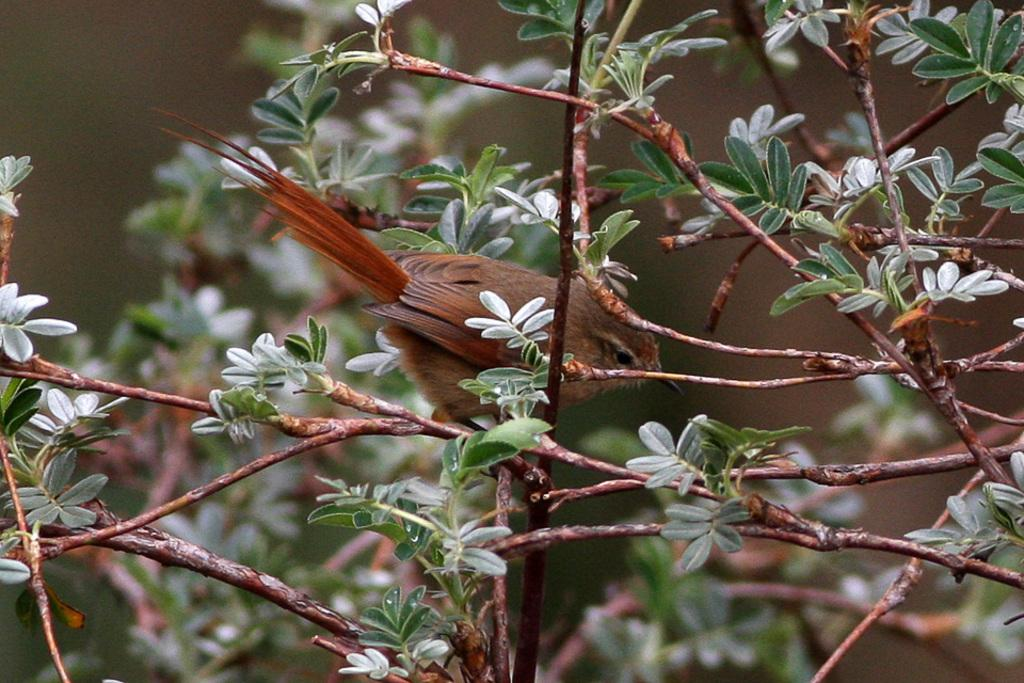What type of animal can be seen in the image? There is a bird in the image. Where is the bird located? The bird is on a plant. What is the color of the bird? The bird is in brown color. Can you describe the background of the image? The background of the image is blurred. What type of action is the nail performing in the image? There is no nail present in the image, so it is not possible to answer that question. 